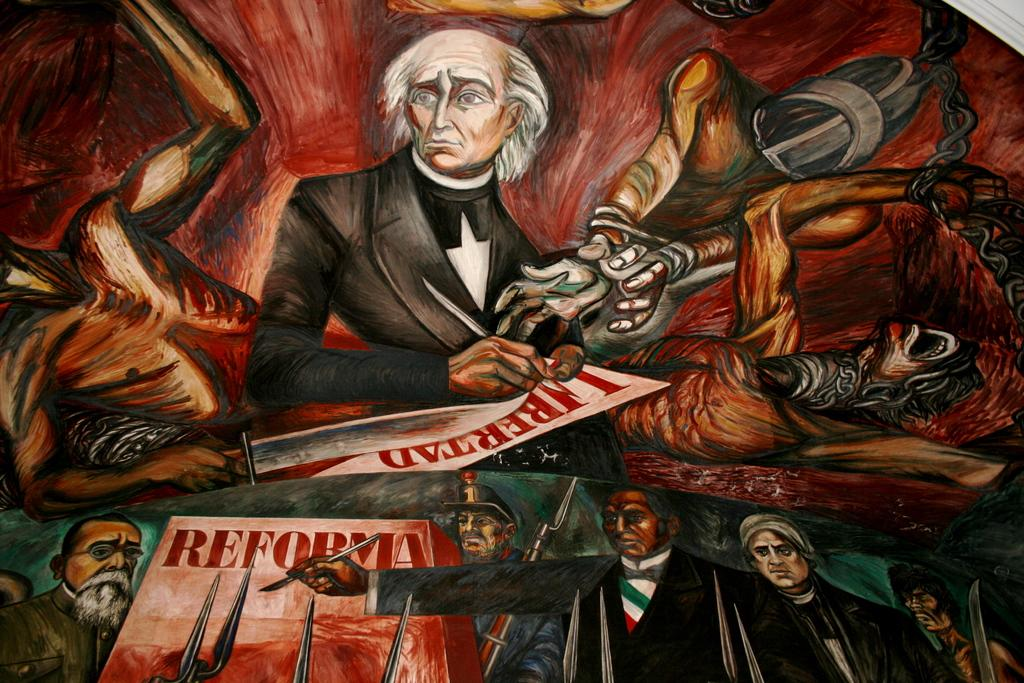<image>
Share a concise interpretation of the image provided. A painting of men which states reforma at the bottom 